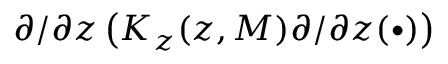<formula> <loc_0><loc_0><loc_500><loc_500>\partial / \partial z \left ( K _ { z } ( z , M ) \partial / \partial z ( \bullet ) \right )</formula> 